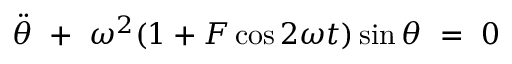Convert formula to latex. <formula><loc_0><loc_0><loc_500><loc_500>\ D d o t { \theta } \ + \ \omega ^ { 2 } ( 1 + F \cos 2 \omega t ) \sin \theta \ = \ 0</formula> 